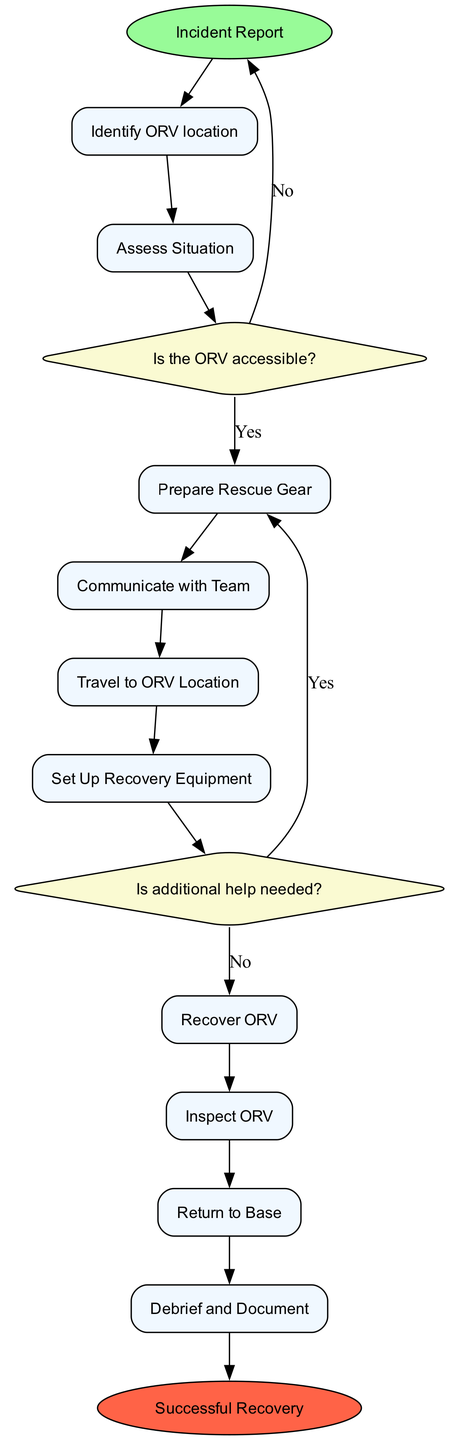What is the starting point of the diagram? The starting point, indicated in the diagram, is the "Incident Report" node where the notification of a stranded ORV is received.
Answer: Incident Report How many activities are there in total? The diagram lists several activities that need to be undertaken for the recovery process. Counting them gives a total of ten activities.
Answer: 10 What is the last activity before reaching the end? The last activity before reaching the end node is "Debrief and Document," which involves holding a meeting to document the incident and learnings.
Answer: Debrief and Document What decision follows the "Assess Situation" activity? After "Assess Situation," the diagram shows a decision node labeled "Is the ORV accessible?" which evaluates the ease of reaching the stranded ORV.
Answer: Is the ORV accessible? If the ORV is not accessible, where does the process lead? If the decision indicates that the ORV is not accessible, the flow leads back to the starting point of the diagram, represented by the "Incident Report" node.
Answer: Incident Report What type of node is used for "Prepare Rescue Gear"? The "Prepare Rescue Gear" node is categorized as an action node, represented with a rectangular shape and describes the activity of gathering recovery equipment.
Answer: Action Node How many decision points are in the diagram? The diagram contains two decision points indicated by the diamond-shaped nodes that guide the recovery process based on situational assessments.
Answer: 2 What happens after the "Recover ORV" activity? After the "Recover ORV" activity, the next step in the sequence is the "Inspect ORV" activity, which involves checking the ORV for any damages or issues post-recovery.
Answer: Inspect ORV 